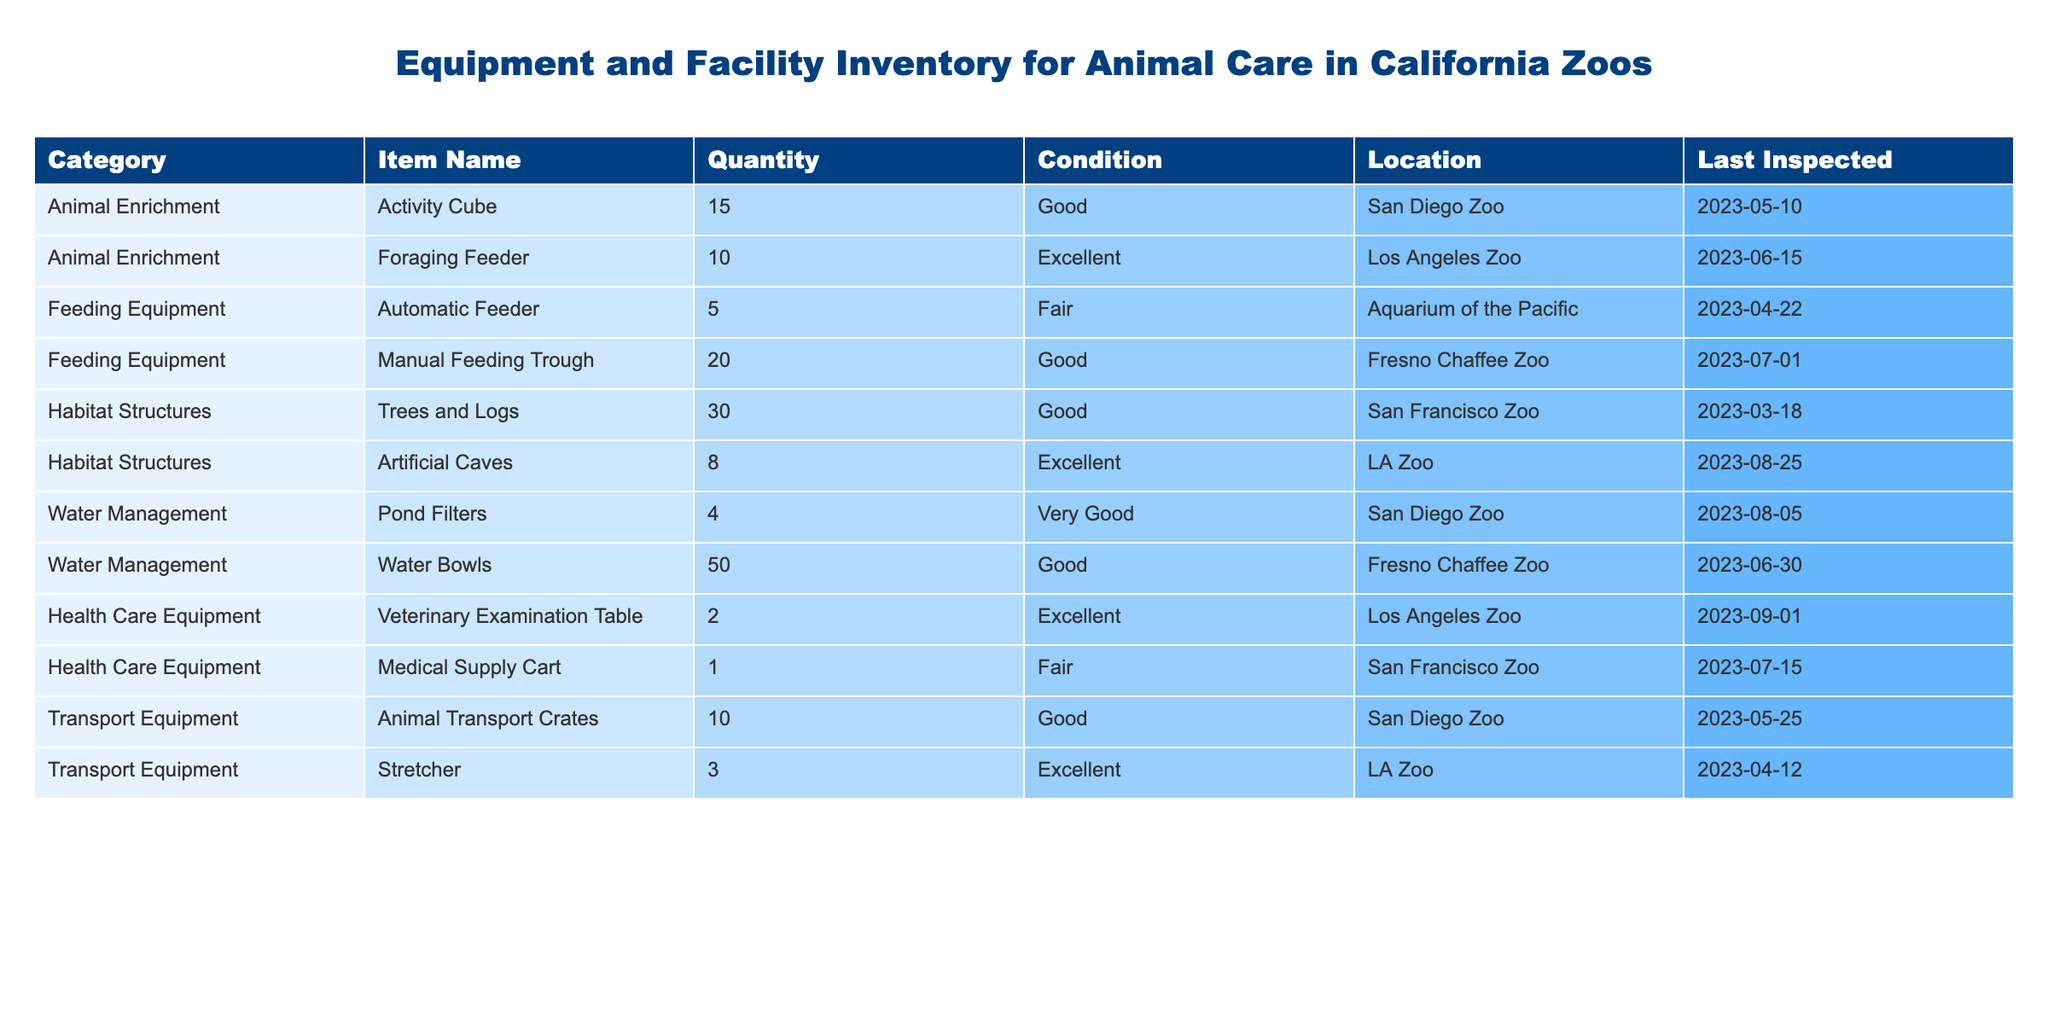What is the total quantity of Animal Enrichment items? There are two types of Animal Enrichment items listed: Activity Cube (15) and Foraging Feeder (10). Adding these quantities gives us a total of 15 + 10 = 25.
Answer: 25 Which zoo has the highest quantity of Feeding Equipment? The Feeding Equipment listed includes Automatic Feeder (5) at Aquarium of the Pacific and Manual Feeding Trough (20) at Fresno Chaffee Zoo. Comparing the two, 20 (Fresno Chaffee Zoo) is greater than 5 (Aquarium of the Pacific). Thus, Fresno Chaffee Zoo has the highest quantity at 20.
Answer: Fresno Chaffee Zoo with 20 Is the Medical Supply Cart in Fair condition? According to the table, the Medical Supply Cart is noted as "Fair". Therefore, the statement is true.
Answer: Yes What is the average number of Water Management items across the locations? The Water Management items listed are Pond Filters (4) and Water Bowls (50). To find the average, we add these quantities (4 + 50 = 54) and divide by the number of items (2): 54/2 = 27.
Answer: 27 How many facilities have Equipment in Excellent condition? From the table, the items in Excellent condition are Foraging Feeder (Los Angeles Zoo), Artificial Caves (LA Zoo), Veterinary Examination Table (Los Angeles Zoo), and Stretcher (LA Zoo). There are 4 items, so 3 locations are involved (LA Zoo and Los Angeles Zoo).
Answer: 3 locations What percentage of the total inventory consists of Habitat Structures? There are two Habitat Structures listed: Trees and Logs (30) and Artificial Caves (8). The total inventory across all items can be calculated as 15 + 10 + 5 + 20 + 30 + 8 + 4 + 50 + 2 + 1 + 10 + 3 = 164. Total Habitat Structures: 30 + 8 = 38. To find the percentage: (38/164) * 100 = 23.17%.
Answer: 23.17% Does San Diego Zoo have any items in Fair condition? The table shows the conditioned items at San Diego Zoo: Activity Cube (Good), Pond Filters (Very Good), and Animal Transport Crates (Good). However, none are listed as Fair, meaning the statement is false.
Answer: No Which location has the least quantity of Health Care Equipment? The Health Care Equipment is listed as Veterinary Examination Table (2) at Los Angeles Zoo and Medical Supply Cart (1) at San Francisco Zoo. Comparing these quantities, 1 (San Francisco Zoo) is less than 2 (Los Angeles Zoo). Therefore, San Francisco Zoo has the least quantity at 1.
Answer: San Francisco Zoo with 1 